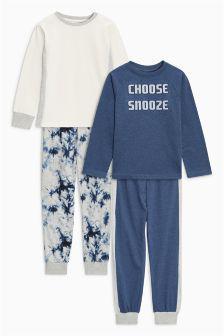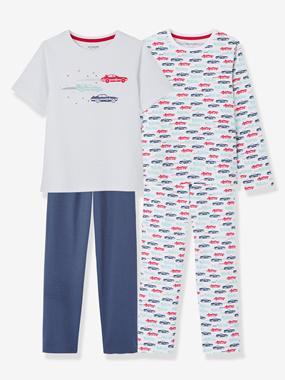The first image is the image on the left, the second image is the image on the right. Evaluate the accuracy of this statement regarding the images: "An image includes a short-sleeve top and a pair of striped pants.". Is it true? Answer yes or no. No. The first image is the image on the left, the second image is the image on the right. Examine the images to the left and right. Is the description "None of the pants have vertical or horizontal stripes." accurate? Answer yes or no. Yes. 